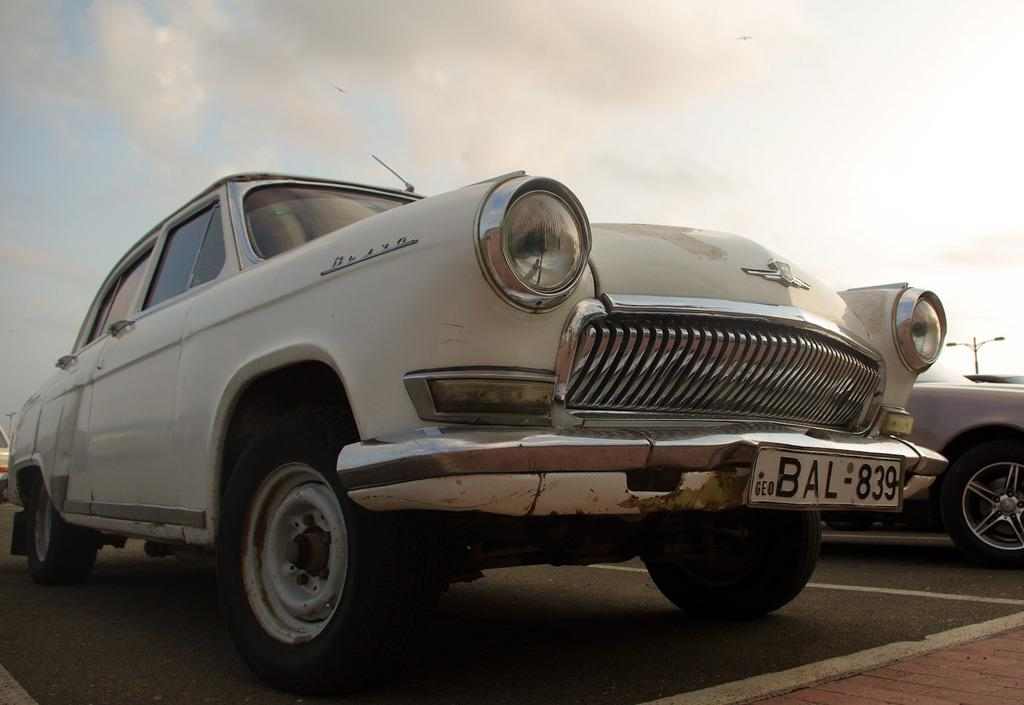What color are the cars in the image? The cars in the image are white. What can be seen on the right side of the background in the image? There are street lamps. What is visible at the top of the image? The sky is visible at the top of the image. What can be observed in the sky in the image? There are clouds in the sky. What type of ink is being used to write on the car in the image? There is no ink or writing on the car in the image; it is a simple image of white cars. 